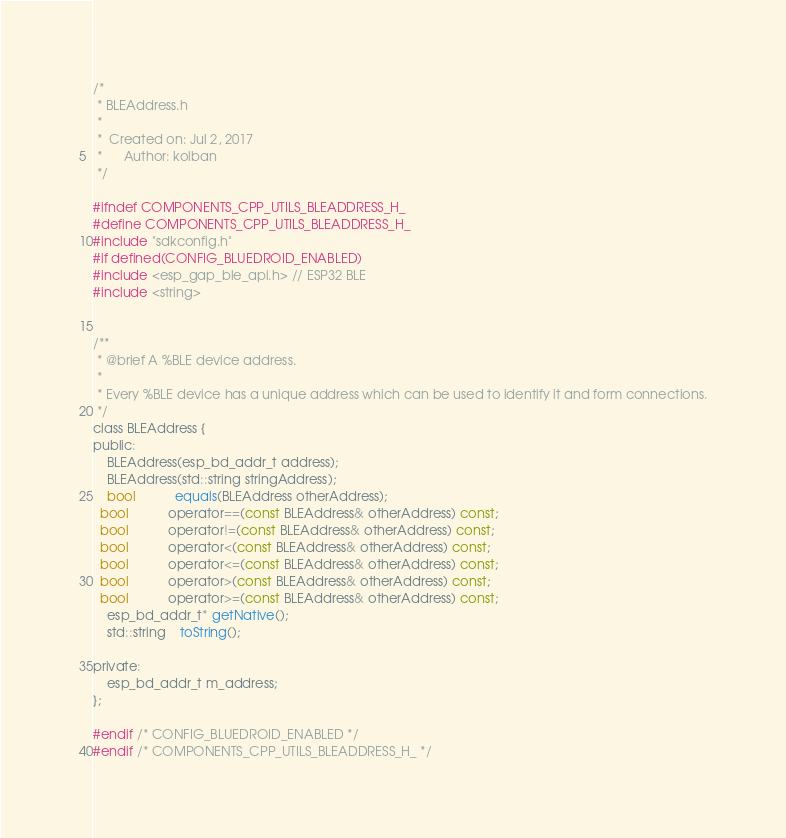<code> <loc_0><loc_0><loc_500><loc_500><_C_>/*
 * BLEAddress.h
 *
 *  Created on: Jul 2, 2017
 *      Author: kolban
 */

#ifndef COMPONENTS_CPP_UTILS_BLEADDRESS_H_
#define COMPONENTS_CPP_UTILS_BLEADDRESS_H_
#include "sdkconfig.h"
#if defined(CONFIG_BLUEDROID_ENABLED)
#include <esp_gap_ble_api.h> // ESP32 BLE
#include <string>


/**
 * @brief A %BLE device address.
 *
 * Every %BLE device has a unique address which can be used to identify it and form connections.
 */
class BLEAddress {
public:
	BLEAddress(esp_bd_addr_t address);
	BLEAddress(std::string stringAddress);
	bool           equals(BLEAddress otherAddress);
  bool           operator==(const BLEAddress& otherAddress) const;
  bool           operator!=(const BLEAddress& otherAddress) const;
  bool           operator<(const BLEAddress& otherAddress) const;
  bool           operator<=(const BLEAddress& otherAddress) const;
  bool           operator>(const BLEAddress& otherAddress) const;
  bool           operator>=(const BLEAddress& otherAddress) const;
	esp_bd_addr_t* getNative();
	std::string    toString();

private:
	esp_bd_addr_t m_address;
};

#endif /* CONFIG_BLUEDROID_ENABLED */
#endif /* COMPONENTS_CPP_UTILS_BLEADDRESS_H_ */
</code> 